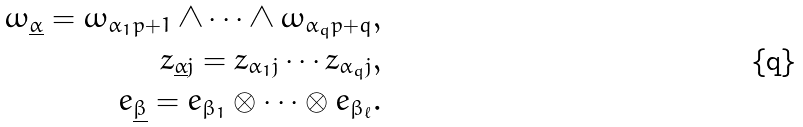Convert formula to latex. <formula><loc_0><loc_0><loc_500><loc_500>\omega _ { \underline { \alpha } } = \omega _ { \alpha _ { 1 } p + 1 } \wedge \cdots \wedge \omega _ { \alpha _ { q } p + q } , \\ z _ { \underline { \alpha } j } = z _ { \alpha _ { 1 } j } \cdots z _ { \alpha _ { q } j } , \\ e _ { \underline { \beta } } = e _ { \beta _ { 1 } } \otimes \cdots \otimes e _ { \beta _ { \ell } } .</formula> 